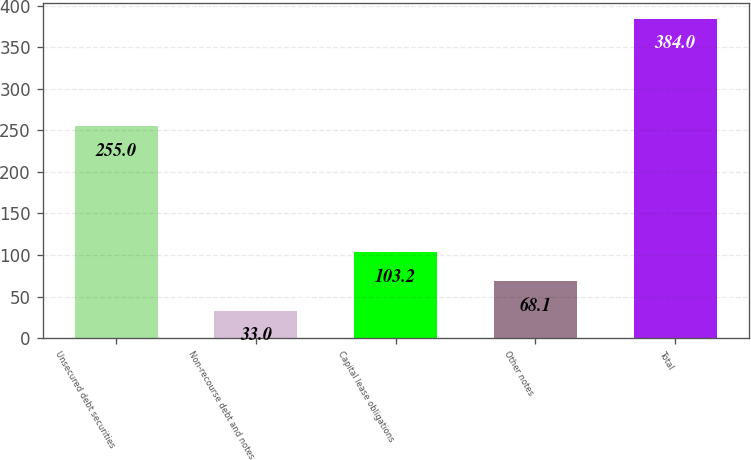Convert chart. <chart><loc_0><loc_0><loc_500><loc_500><bar_chart><fcel>Unsecured debt securities<fcel>Non-recourse debt and notes<fcel>Capital lease obligations<fcel>Other notes<fcel>Total<nl><fcel>255<fcel>33<fcel>103.2<fcel>68.1<fcel>384<nl></chart> 